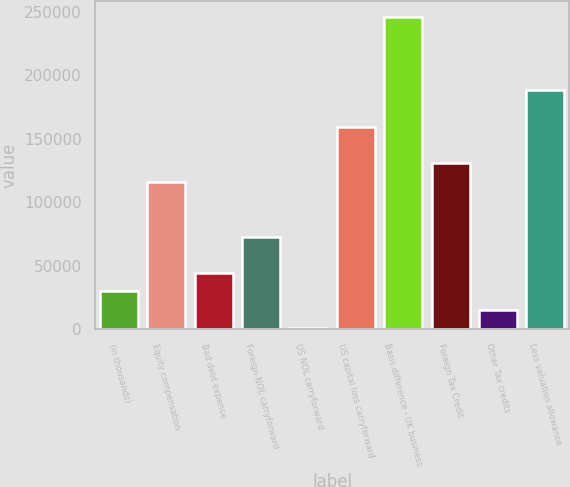Convert chart. <chart><loc_0><loc_0><loc_500><loc_500><bar_chart><fcel>(in thousands)<fcel>Equity compensation<fcel>Bad debt expense<fcel>Foreign NOL carryforward<fcel>US NOL carryforward<fcel>US capital loss carryforward<fcel>Basis difference - UK business<fcel>Foreign Tax Credit<fcel>Other Tax credits<fcel>Less valuation allowance<nl><fcel>29906.8<fcel>116378<fcel>44318.7<fcel>73142.5<fcel>1083<fcel>159614<fcel>246085<fcel>130790<fcel>15494.9<fcel>188438<nl></chart> 